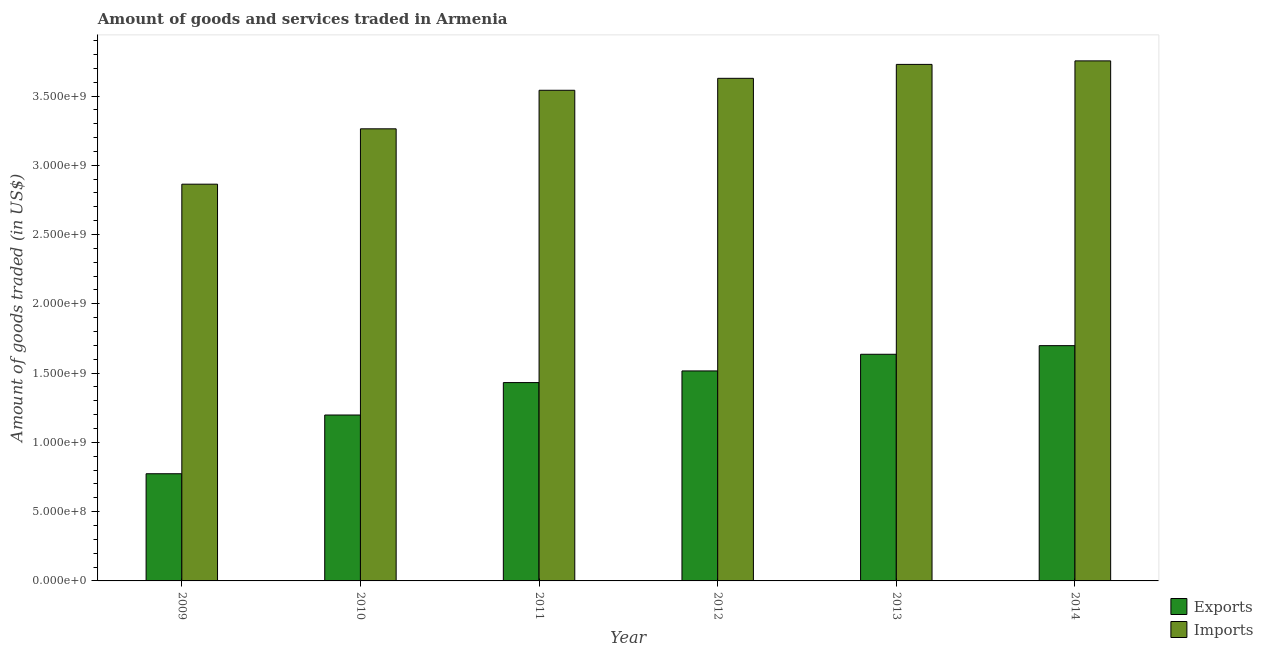How many different coloured bars are there?
Offer a very short reply. 2. Are the number of bars on each tick of the X-axis equal?
Provide a short and direct response. Yes. How many bars are there on the 2nd tick from the right?
Your answer should be very brief. 2. What is the label of the 3rd group of bars from the left?
Offer a terse response. 2011. In how many cases, is the number of bars for a given year not equal to the number of legend labels?
Ensure brevity in your answer.  0. What is the amount of goods exported in 2011?
Your answer should be compact. 1.43e+09. Across all years, what is the maximum amount of goods imported?
Your response must be concise. 3.75e+09. Across all years, what is the minimum amount of goods imported?
Make the answer very short. 2.86e+09. What is the total amount of goods exported in the graph?
Ensure brevity in your answer.  8.25e+09. What is the difference between the amount of goods imported in 2009 and that in 2012?
Your answer should be very brief. -7.64e+08. What is the difference between the amount of goods exported in 2011 and the amount of goods imported in 2014?
Offer a terse response. -2.67e+08. What is the average amount of goods exported per year?
Offer a very short reply. 1.38e+09. In how many years, is the amount of goods exported greater than 800000000 US$?
Make the answer very short. 5. What is the ratio of the amount of goods imported in 2009 to that in 2010?
Your answer should be compact. 0.88. Is the amount of goods exported in 2009 less than that in 2010?
Provide a succinct answer. Yes. What is the difference between the highest and the second highest amount of goods imported?
Your answer should be very brief. 2.54e+07. What is the difference between the highest and the lowest amount of goods imported?
Provide a succinct answer. 8.90e+08. What does the 1st bar from the left in 2010 represents?
Provide a succinct answer. Exports. What does the 2nd bar from the right in 2010 represents?
Offer a terse response. Exports. Are the values on the major ticks of Y-axis written in scientific E-notation?
Provide a short and direct response. Yes. Does the graph contain grids?
Provide a short and direct response. No. Where does the legend appear in the graph?
Your answer should be very brief. Bottom right. How are the legend labels stacked?
Your answer should be compact. Vertical. What is the title of the graph?
Offer a very short reply. Amount of goods and services traded in Armenia. What is the label or title of the Y-axis?
Provide a short and direct response. Amount of goods traded (in US$). What is the Amount of goods traded (in US$) of Exports in 2009?
Ensure brevity in your answer.  7.74e+08. What is the Amount of goods traded (in US$) of Imports in 2009?
Keep it short and to the point. 2.86e+09. What is the Amount of goods traded (in US$) in Exports in 2010?
Offer a terse response. 1.20e+09. What is the Amount of goods traded (in US$) in Imports in 2010?
Provide a short and direct response. 3.26e+09. What is the Amount of goods traded (in US$) of Exports in 2011?
Keep it short and to the point. 1.43e+09. What is the Amount of goods traded (in US$) of Imports in 2011?
Offer a very short reply. 3.54e+09. What is the Amount of goods traded (in US$) in Exports in 2012?
Give a very brief answer. 1.52e+09. What is the Amount of goods traded (in US$) of Imports in 2012?
Your answer should be very brief. 3.63e+09. What is the Amount of goods traded (in US$) in Exports in 2013?
Your response must be concise. 1.64e+09. What is the Amount of goods traded (in US$) in Imports in 2013?
Make the answer very short. 3.73e+09. What is the Amount of goods traded (in US$) in Exports in 2014?
Provide a succinct answer. 1.70e+09. What is the Amount of goods traded (in US$) of Imports in 2014?
Your answer should be compact. 3.75e+09. Across all years, what is the maximum Amount of goods traded (in US$) of Exports?
Provide a succinct answer. 1.70e+09. Across all years, what is the maximum Amount of goods traded (in US$) in Imports?
Offer a very short reply. 3.75e+09. Across all years, what is the minimum Amount of goods traded (in US$) of Exports?
Ensure brevity in your answer.  7.74e+08. Across all years, what is the minimum Amount of goods traded (in US$) of Imports?
Give a very brief answer. 2.86e+09. What is the total Amount of goods traded (in US$) of Exports in the graph?
Provide a short and direct response. 8.25e+09. What is the total Amount of goods traded (in US$) in Imports in the graph?
Make the answer very short. 2.08e+1. What is the difference between the Amount of goods traded (in US$) in Exports in 2009 and that in 2010?
Offer a terse response. -4.24e+08. What is the difference between the Amount of goods traded (in US$) in Imports in 2009 and that in 2010?
Provide a short and direct response. -4.00e+08. What is the difference between the Amount of goods traded (in US$) in Exports in 2009 and that in 2011?
Your answer should be very brief. -6.58e+08. What is the difference between the Amount of goods traded (in US$) of Imports in 2009 and that in 2011?
Provide a short and direct response. -6.78e+08. What is the difference between the Amount of goods traded (in US$) in Exports in 2009 and that in 2012?
Offer a very short reply. -7.42e+08. What is the difference between the Amount of goods traded (in US$) in Imports in 2009 and that in 2012?
Offer a terse response. -7.64e+08. What is the difference between the Amount of goods traded (in US$) in Exports in 2009 and that in 2013?
Provide a succinct answer. -8.62e+08. What is the difference between the Amount of goods traded (in US$) of Imports in 2009 and that in 2013?
Your answer should be compact. -8.65e+08. What is the difference between the Amount of goods traded (in US$) of Exports in 2009 and that in 2014?
Make the answer very short. -9.25e+08. What is the difference between the Amount of goods traded (in US$) of Imports in 2009 and that in 2014?
Your answer should be very brief. -8.90e+08. What is the difference between the Amount of goods traded (in US$) of Exports in 2010 and that in 2011?
Give a very brief answer. -2.34e+08. What is the difference between the Amount of goods traded (in US$) in Imports in 2010 and that in 2011?
Ensure brevity in your answer.  -2.78e+08. What is the difference between the Amount of goods traded (in US$) in Exports in 2010 and that in 2012?
Offer a very short reply. -3.18e+08. What is the difference between the Amount of goods traded (in US$) in Imports in 2010 and that in 2012?
Offer a very short reply. -3.64e+08. What is the difference between the Amount of goods traded (in US$) of Exports in 2010 and that in 2013?
Offer a terse response. -4.38e+08. What is the difference between the Amount of goods traded (in US$) in Imports in 2010 and that in 2013?
Provide a succinct answer. -4.65e+08. What is the difference between the Amount of goods traded (in US$) of Exports in 2010 and that in 2014?
Give a very brief answer. -5.01e+08. What is the difference between the Amount of goods traded (in US$) in Imports in 2010 and that in 2014?
Provide a short and direct response. -4.90e+08. What is the difference between the Amount of goods traded (in US$) of Exports in 2011 and that in 2012?
Keep it short and to the point. -8.41e+07. What is the difference between the Amount of goods traded (in US$) in Imports in 2011 and that in 2012?
Ensure brevity in your answer.  -8.62e+07. What is the difference between the Amount of goods traded (in US$) of Exports in 2011 and that in 2013?
Your response must be concise. -2.04e+08. What is the difference between the Amount of goods traded (in US$) of Imports in 2011 and that in 2013?
Provide a short and direct response. -1.87e+08. What is the difference between the Amount of goods traded (in US$) of Exports in 2011 and that in 2014?
Provide a succinct answer. -2.67e+08. What is the difference between the Amount of goods traded (in US$) in Imports in 2011 and that in 2014?
Offer a terse response. -2.12e+08. What is the difference between the Amount of goods traded (in US$) in Exports in 2012 and that in 2013?
Your answer should be compact. -1.20e+08. What is the difference between the Amount of goods traded (in US$) in Imports in 2012 and that in 2013?
Keep it short and to the point. -1.01e+08. What is the difference between the Amount of goods traded (in US$) of Exports in 2012 and that in 2014?
Offer a very short reply. -1.82e+08. What is the difference between the Amount of goods traded (in US$) of Imports in 2012 and that in 2014?
Offer a very short reply. -1.26e+08. What is the difference between the Amount of goods traded (in US$) in Exports in 2013 and that in 2014?
Offer a very short reply. -6.23e+07. What is the difference between the Amount of goods traded (in US$) in Imports in 2013 and that in 2014?
Offer a very short reply. -2.54e+07. What is the difference between the Amount of goods traded (in US$) in Exports in 2009 and the Amount of goods traded (in US$) in Imports in 2010?
Your response must be concise. -2.49e+09. What is the difference between the Amount of goods traded (in US$) of Exports in 2009 and the Amount of goods traded (in US$) of Imports in 2011?
Provide a short and direct response. -2.77e+09. What is the difference between the Amount of goods traded (in US$) of Exports in 2009 and the Amount of goods traded (in US$) of Imports in 2012?
Offer a terse response. -2.85e+09. What is the difference between the Amount of goods traded (in US$) of Exports in 2009 and the Amount of goods traded (in US$) of Imports in 2013?
Your answer should be very brief. -2.95e+09. What is the difference between the Amount of goods traded (in US$) in Exports in 2009 and the Amount of goods traded (in US$) in Imports in 2014?
Ensure brevity in your answer.  -2.98e+09. What is the difference between the Amount of goods traded (in US$) of Exports in 2010 and the Amount of goods traded (in US$) of Imports in 2011?
Provide a succinct answer. -2.34e+09. What is the difference between the Amount of goods traded (in US$) in Exports in 2010 and the Amount of goods traded (in US$) in Imports in 2012?
Provide a short and direct response. -2.43e+09. What is the difference between the Amount of goods traded (in US$) of Exports in 2010 and the Amount of goods traded (in US$) of Imports in 2013?
Keep it short and to the point. -2.53e+09. What is the difference between the Amount of goods traded (in US$) of Exports in 2010 and the Amount of goods traded (in US$) of Imports in 2014?
Provide a short and direct response. -2.56e+09. What is the difference between the Amount of goods traded (in US$) in Exports in 2011 and the Amount of goods traded (in US$) in Imports in 2012?
Offer a terse response. -2.20e+09. What is the difference between the Amount of goods traded (in US$) of Exports in 2011 and the Amount of goods traded (in US$) of Imports in 2013?
Give a very brief answer. -2.30e+09. What is the difference between the Amount of goods traded (in US$) of Exports in 2011 and the Amount of goods traded (in US$) of Imports in 2014?
Ensure brevity in your answer.  -2.32e+09. What is the difference between the Amount of goods traded (in US$) in Exports in 2012 and the Amount of goods traded (in US$) in Imports in 2013?
Offer a very short reply. -2.21e+09. What is the difference between the Amount of goods traded (in US$) in Exports in 2012 and the Amount of goods traded (in US$) in Imports in 2014?
Provide a short and direct response. -2.24e+09. What is the difference between the Amount of goods traded (in US$) in Exports in 2013 and the Amount of goods traded (in US$) in Imports in 2014?
Keep it short and to the point. -2.12e+09. What is the average Amount of goods traded (in US$) of Exports per year?
Your answer should be very brief. 1.38e+09. What is the average Amount of goods traded (in US$) of Imports per year?
Ensure brevity in your answer.  3.46e+09. In the year 2009, what is the difference between the Amount of goods traded (in US$) in Exports and Amount of goods traded (in US$) in Imports?
Provide a succinct answer. -2.09e+09. In the year 2010, what is the difference between the Amount of goods traded (in US$) in Exports and Amount of goods traded (in US$) in Imports?
Provide a succinct answer. -2.07e+09. In the year 2011, what is the difference between the Amount of goods traded (in US$) of Exports and Amount of goods traded (in US$) of Imports?
Make the answer very short. -2.11e+09. In the year 2012, what is the difference between the Amount of goods traded (in US$) of Exports and Amount of goods traded (in US$) of Imports?
Provide a succinct answer. -2.11e+09. In the year 2013, what is the difference between the Amount of goods traded (in US$) in Exports and Amount of goods traded (in US$) in Imports?
Ensure brevity in your answer.  -2.09e+09. In the year 2014, what is the difference between the Amount of goods traded (in US$) in Exports and Amount of goods traded (in US$) in Imports?
Ensure brevity in your answer.  -2.06e+09. What is the ratio of the Amount of goods traded (in US$) in Exports in 2009 to that in 2010?
Give a very brief answer. 0.65. What is the ratio of the Amount of goods traded (in US$) of Imports in 2009 to that in 2010?
Your answer should be compact. 0.88. What is the ratio of the Amount of goods traded (in US$) in Exports in 2009 to that in 2011?
Give a very brief answer. 0.54. What is the ratio of the Amount of goods traded (in US$) of Imports in 2009 to that in 2011?
Make the answer very short. 0.81. What is the ratio of the Amount of goods traded (in US$) in Exports in 2009 to that in 2012?
Ensure brevity in your answer.  0.51. What is the ratio of the Amount of goods traded (in US$) of Imports in 2009 to that in 2012?
Provide a succinct answer. 0.79. What is the ratio of the Amount of goods traded (in US$) of Exports in 2009 to that in 2013?
Make the answer very short. 0.47. What is the ratio of the Amount of goods traded (in US$) of Imports in 2009 to that in 2013?
Give a very brief answer. 0.77. What is the ratio of the Amount of goods traded (in US$) of Exports in 2009 to that in 2014?
Your answer should be very brief. 0.46. What is the ratio of the Amount of goods traded (in US$) of Imports in 2009 to that in 2014?
Your answer should be very brief. 0.76. What is the ratio of the Amount of goods traded (in US$) of Exports in 2010 to that in 2011?
Provide a succinct answer. 0.84. What is the ratio of the Amount of goods traded (in US$) of Imports in 2010 to that in 2011?
Make the answer very short. 0.92. What is the ratio of the Amount of goods traded (in US$) of Exports in 2010 to that in 2012?
Provide a short and direct response. 0.79. What is the ratio of the Amount of goods traded (in US$) in Imports in 2010 to that in 2012?
Your answer should be compact. 0.9. What is the ratio of the Amount of goods traded (in US$) in Exports in 2010 to that in 2013?
Ensure brevity in your answer.  0.73. What is the ratio of the Amount of goods traded (in US$) in Imports in 2010 to that in 2013?
Keep it short and to the point. 0.88. What is the ratio of the Amount of goods traded (in US$) of Exports in 2010 to that in 2014?
Make the answer very short. 0.71. What is the ratio of the Amount of goods traded (in US$) in Imports in 2010 to that in 2014?
Give a very brief answer. 0.87. What is the ratio of the Amount of goods traded (in US$) in Exports in 2011 to that in 2012?
Keep it short and to the point. 0.94. What is the ratio of the Amount of goods traded (in US$) in Imports in 2011 to that in 2012?
Offer a very short reply. 0.98. What is the ratio of the Amount of goods traded (in US$) of Exports in 2011 to that in 2013?
Your response must be concise. 0.88. What is the ratio of the Amount of goods traded (in US$) in Imports in 2011 to that in 2013?
Provide a succinct answer. 0.95. What is the ratio of the Amount of goods traded (in US$) of Exports in 2011 to that in 2014?
Offer a terse response. 0.84. What is the ratio of the Amount of goods traded (in US$) of Imports in 2011 to that in 2014?
Provide a succinct answer. 0.94. What is the ratio of the Amount of goods traded (in US$) in Exports in 2012 to that in 2013?
Offer a very short reply. 0.93. What is the ratio of the Amount of goods traded (in US$) in Exports in 2012 to that in 2014?
Ensure brevity in your answer.  0.89. What is the ratio of the Amount of goods traded (in US$) in Imports in 2012 to that in 2014?
Make the answer very short. 0.97. What is the ratio of the Amount of goods traded (in US$) of Exports in 2013 to that in 2014?
Provide a succinct answer. 0.96. What is the ratio of the Amount of goods traded (in US$) in Imports in 2013 to that in 2014?
Provide a short and direct response. 0.99. What is the difference between the highest and the second highest Amount of goods traded (in US$) of Exports?
Provide a succinct answer. 6.23e+07. What is the difference between the highest and the second highest Amount of goods traded (in US$) in Imports?
Offer a very short reply. 2.54e+07. What is the difference between the highest and the lowest Amount of goods traded (in US$) in Exports?
Offer a very short reply. 9.25e+08. What is the difference between the highest and the lowest Amount of goods traded (in US$) of Imports?
Offer a very short reply. 8.90e+08. 